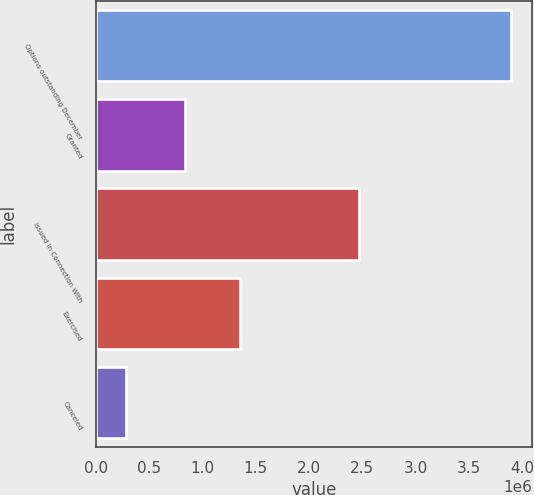Convert chart to OTSL. <chart><loc_0><loc_0><loc_500><loc_500><bar_chart><fcel>Options outstanding December<fcel>Granted<fcel>Issued in Connection With<fcel>Exercised<fcel>Canceled<nl><fcel>3.89682e+06<fcel>840737<fcel>2.46714e+06<fcel>1.35498e+06<fcel>286566<nl></chart> 